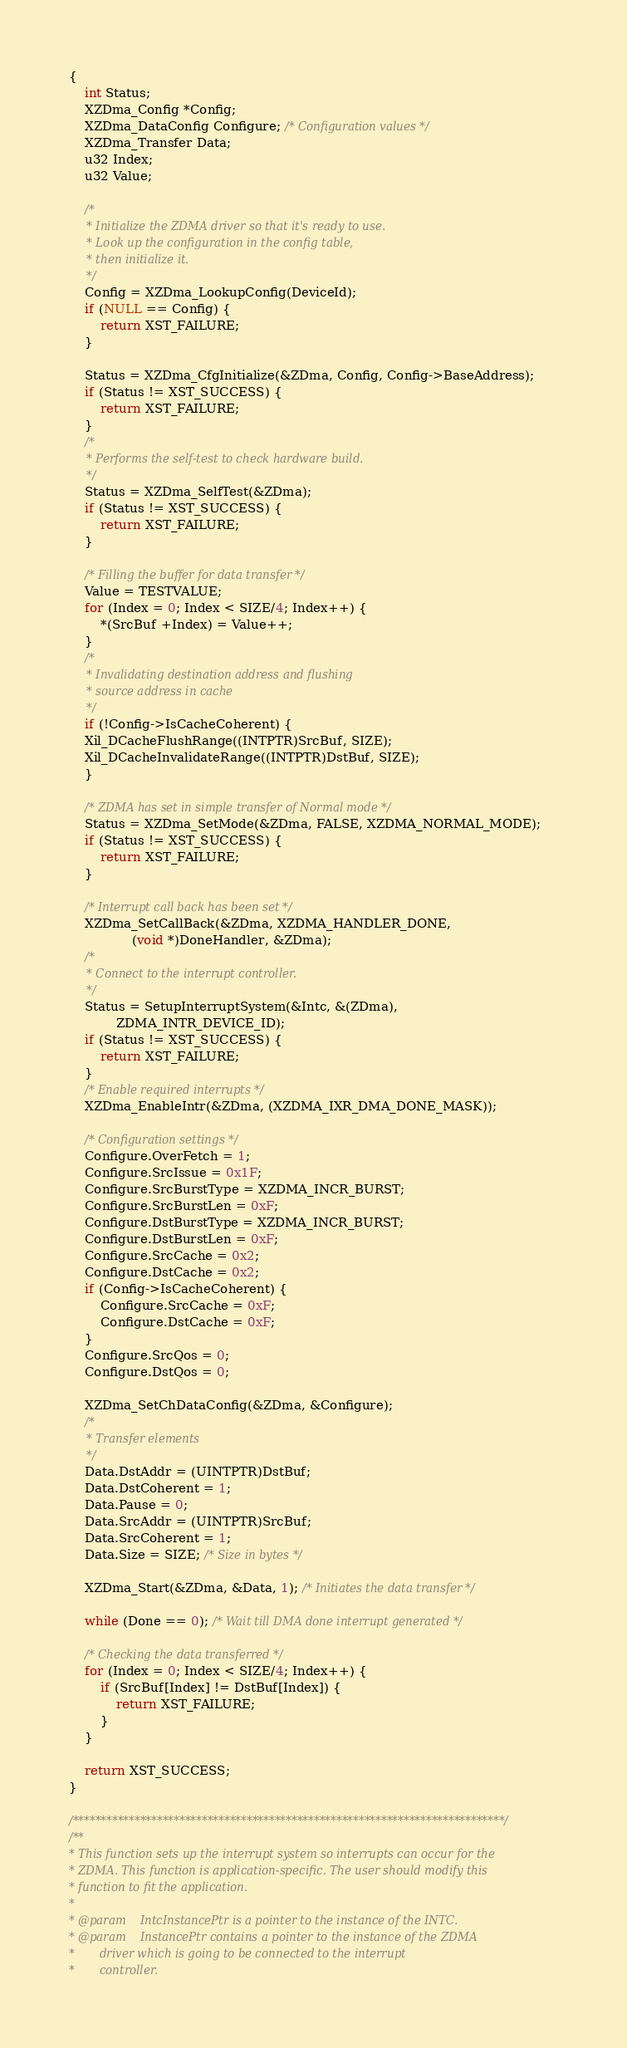<code> <loc_0><loc_0><loc_500><loc_500><_C_>{
	int Status;
	XZDma_Config *Config;
	XZDma_DataConfig Configure; /* Configuration values */
	XZDma_Transfer Data;
	u32 Index;
	u32 Value;

	/*
	 * Initialize the ZDMA driver so that it's ready to use.
	 * Look up the configuration in the config table,
	 * then initialize it.
	 */
	Config = XZDma_LookupConfig(DeviceId);
	if (NULL == Config) {
		return XST_FAILURE;
	}

	Status = XZDma_CfgInitialize(&ZDma, Config, Config->BaseAddress);
	if (Status != XST_SUCCESS) {
		return XST_FAILURE;
	}
	/*
	 * Performs the self-test to check hardware build.
	 */
	Status = XZDma_SelfTest(&ZDma);
	if (Status != XST_SUCCESS) {
		return XST_FAILURE;
	}

	/* Filling the buffer for data transfer */
	Value = TESTVALUE;
	for (Index = 0; Index < SIZE/4; Index++) {
		*(SrcBuf +Index) = Value++;
	}
	/*
	 * Invalidating destination address and flushing
	 * source address in cache
	 */
	if (!Config->IsCacheCoherent) {
	Xil_DCacheFlushRange((INTPTR)SrcBuf, SIZE);
	Xil_DCacheInvalidateRange((INTPTR)DstBuf, SIZE);
	}

	/* ZDMA has set in simple transfer of Normal mode */
	Status = XZDma_SetMode(&ZDma, FALSE, XZDMA_NORMAL_MODE);
	if (Status != XST_SUCCESS) {
		return XST_FAILURE;
	}

	/* Interrupt call back has been set */
	XZDma_SetCallBack(&ZDma, XZDMA_HANDLER_DONE,
				(void *)DoneHandler, &ZDma);
	/*
	 * Connect to the interrupt controller.
	 */
	Status = SetupInterruptSystem(&Intc, &(ZDma),
			ZDMA_INTR_DEVICE_ID);
	if (Status != XST_SUCCESS) {
		return XST_FAILURE;
	}
	/* Enable required interrupts */
	XZDma_EnableIntr(&ZDma, (XZDMA_IXR_DMA_DONE_MASK));

	/* Configuration settings */
	Configure.OverFetch = 1;
	Configure.SrcIssue = 0x1F;
	Configure.SrcBurstType = XZDMA_INCR_BURST;
	Configure.SrcBurstLen = 0xF;
	Configure.DstBurstType = XZDMA_INCR_BURST;
	Configure.DstBurstLen = 0xF;
	Configure.SrcCache = 0x2;
	Configure.DstCache = 0x2;
	if (Config->IsCacheCoherent) {
		Configure.SrcCache = 0xF;
		Configure.DstCache = 0xF;
	}
	Configure.SrcQos = 0;
	Configure.DstQos = 0;

	XZDma_SetChDataConfig(&ZDma, &Configure);
	/*
	 * Transfer elements
	 */
	Data.DstAddr = (UINTPTR)DstBuf;
	Data.DstCoherent = 1;
	Data.Pause = 0;
	Data.SrcAddr = (UINTPTR)SrcBuf;
	Data.SrcCoherent = 1;
	Data.Size = SIZE; /* Size in bytes */

	XZDma_Start(&ZDma, &Data, 1); /* Initiates the data transfer */

	while (Done == 0); /* Wait till DMA done interrupt generated */

	/* Checking the data transferred */
	for (Index = 0; Index < SIZE/4; Index++) {
		if (SrcBuf[Index] != DstBuf[Index]) {
			return XST_FAILURE;
		}
	}

	return XST_SUCCESS;
}

/*****************************************************************************/
/**
* This function sets up the interrupt system so interrupts can occur for the
* ZDMA. This function is application-specific. The user should modify this
* function to fit the application.
*
* @param	IntcInstancePtr is a pointer to the instance of the INTC.
* @param	InstancePtr contains a pointer to the instance of the ZDMA
*		driver which is going to be connected to the interrupt
*		controller.</code> 